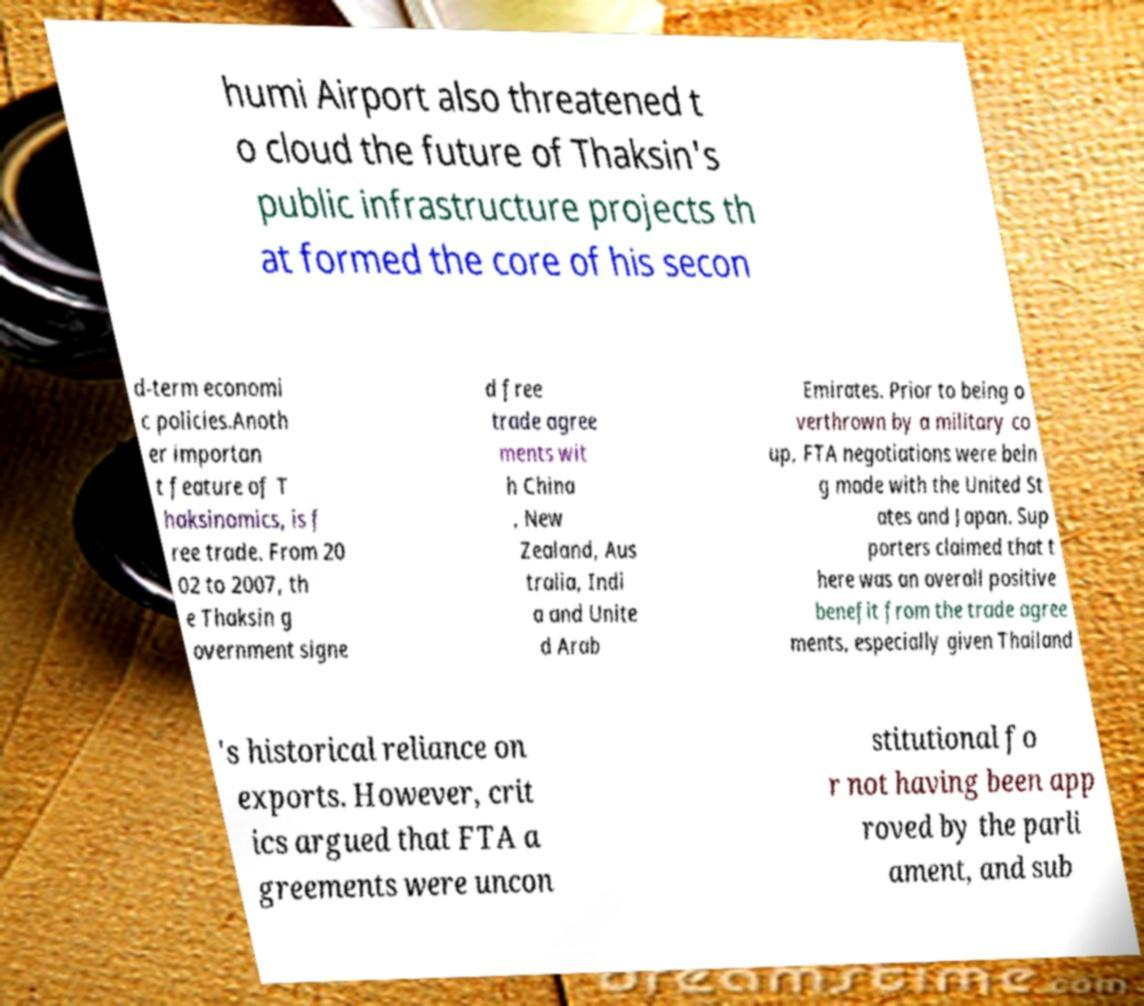Please identify and transcribe the text found in this image. humi Airport also threatened t o cloud the future of Thaksin's public infrastructure projects th at formed the core of his secon d-term economi c policies.Anoth er importan t feature of T haksinomics, is f ree trade. From 20 02 to 2007, th e Thaksin g overnment signe d free trade agree ments wit h China , New Zealand, Aus tralia, Indi a and Unite d Arab Emirates. Prior to being o verthrown by a military co up, FTA negotiations were bein g made with the United St ates and Japan. Sup porters claimed that t here was an overall positive benefit from the trade agree ments, especially given Thailand 's historical reliance on exports. However, crit ics argued that FTA a greements were uncon stitutional fo r not having been app roved by the parli ament, and sub 